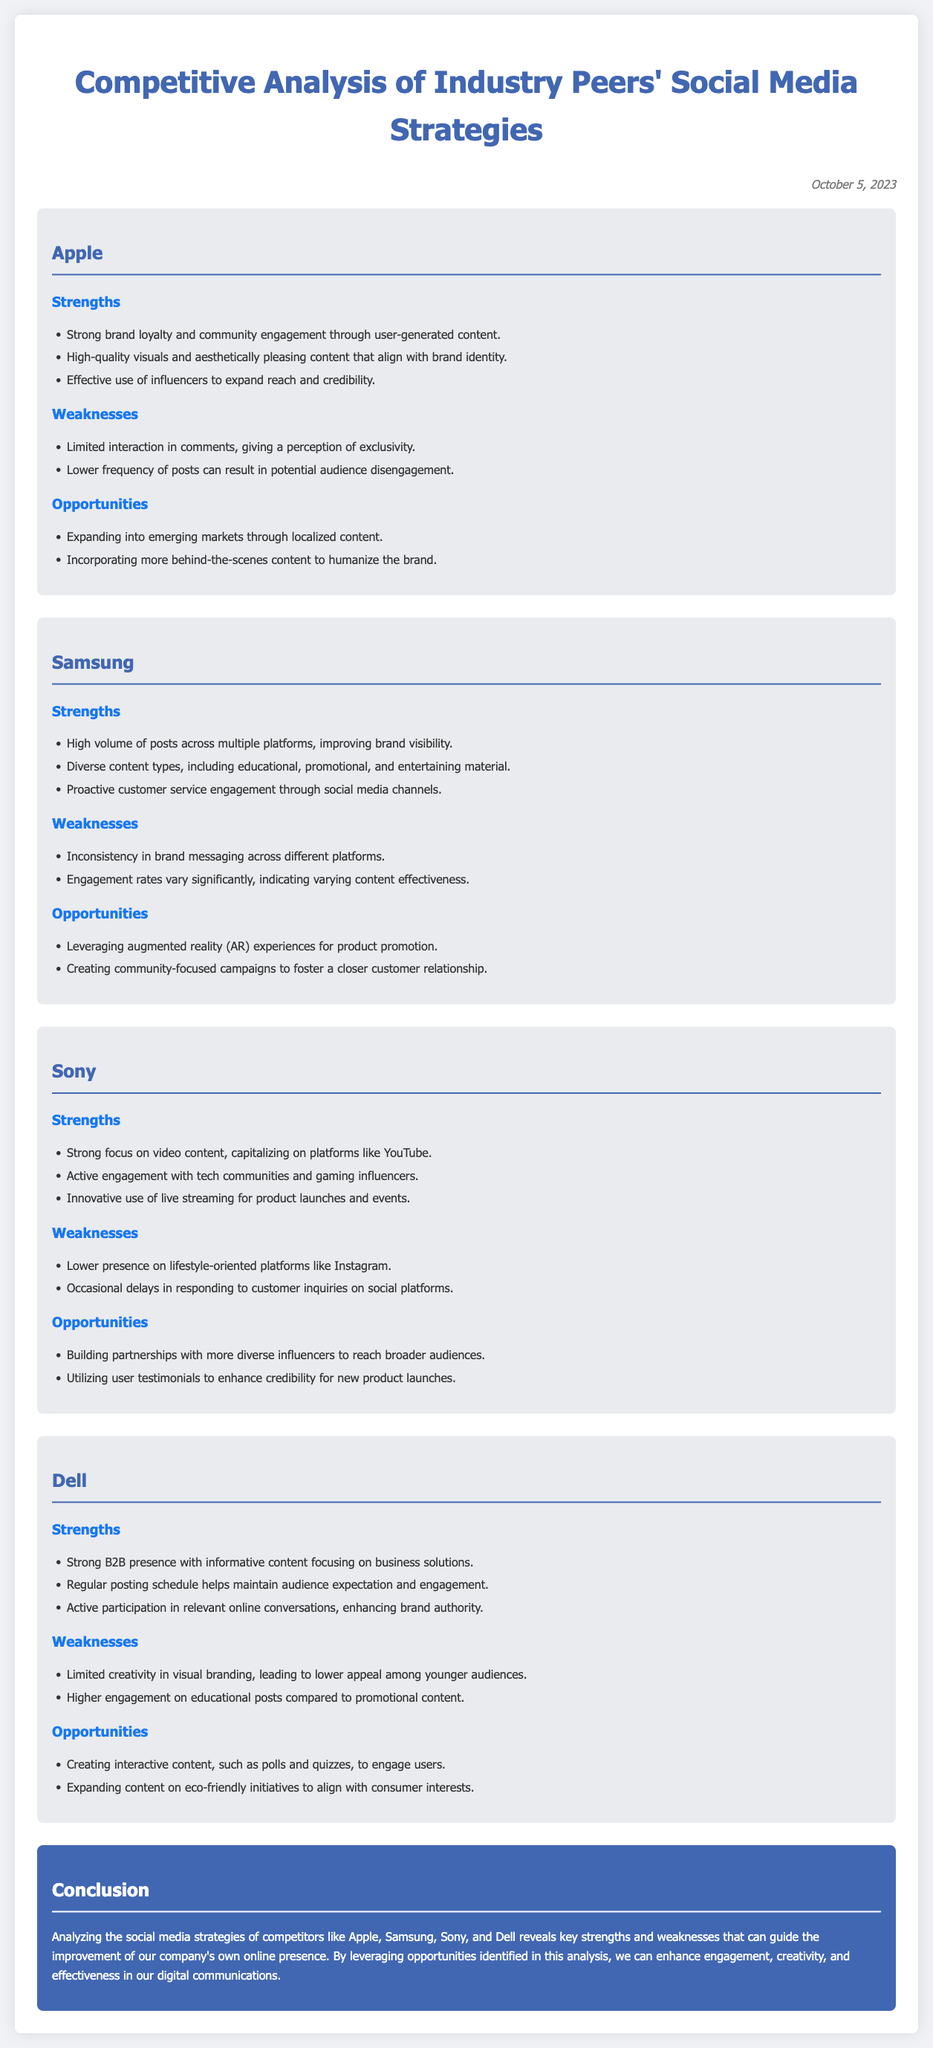What is the date of the analysis? The date is indicated at the top of the document, showing when the analysis was completed.
Answer: October 5, 2023 Which company has strong brand loyalty and community engagement? The strengths section mentions the brand loyalty and community engagement in relation to user-generated content specifically for one company.
Answer: Apple What is a weakness of Samsung's social media strategy? The weaknesses section lists specific weaknesses, one of which emphasizes the inconsistency in brand messaging across platforms.
Answer: Inconsistency in brand messaging Which company utilizes innovative live streaming? The strengths of one company highlight its focus on utilizing live streaming as part of its engagement strategy.
Answer: Sony What opportunity could Dell explore to engage users? The opportunities section suggests a specific type of interactive content that could engage the audience effectively.
Answer: Interactive content How does Sony build engagement with influencers? The strengths section describes how one company's engagement strategy focuses on tech communities and seeks partnerships for broader outreach.
Answer: Gaming influencers What type of content does Dell post regularly? The strengths section highlights Dell's consistent posting schedule focusing on a specific audience.
Answer: Informative content Which company has a high volume of posts for visibility? The strengths section for one company emphasizes its posting frequency across multiple platforms to improve brand visibility.
Answer: Samsung What is one strength of Apple's social media presence? The strengths section specifically mentions a positive aspect related to the brand's engagement strategy through a certain type of content.
Answer: User-generated content 